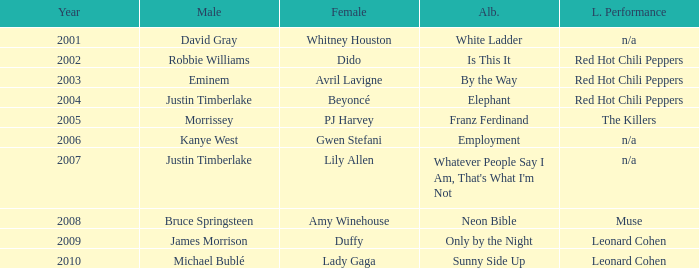Would you mind parsing the complete table? {'header': ['Year', 'Male', 'Female', 'Alb.', 'L. Performance'], 'rows': [['2001', 'David Gray', 'Whitney Houston', 'White Ladder', 'n/a'], ['2002', 'Robbie Williams', 'Dido', 'Is This It', 'Red Hot Chili Peppers'], ['2003', 'Eminem', 'Avril Lavigne', 'By the Way', 'Red Hot Chili Peppers'], ['2004', 'Justin Timberlake', 'Beyoncé', 'Elephant', 'Red Hot Chili Peppers'], ['2005', 'Morrissey', 'PJ Harvey', 'Franz Ferdinand', 'The Killers'], ['2006', 'Kanye West', 'Gwen Stefani', 'Employment', 'n/a'], ['2007', 'Justin Timberlake', 'Lily Allen', "Whatever People Say I Am, That's What I'm Not", 'n/a'], ['2008', 'Bruce Springsteen', 'Amy Winehouse', 'Neon Bible', 'Muse'], ['2009', 'James Morrison', 'Duffy', 'Only by the Night', 'Leonard Cohen'], ['2010', 'Michael Bublé', 'Lady Gaga', 'Sunny Side Up', 'Leonard Cohen']]} Which male is paired with dido in 2004? Robbie Williams. 